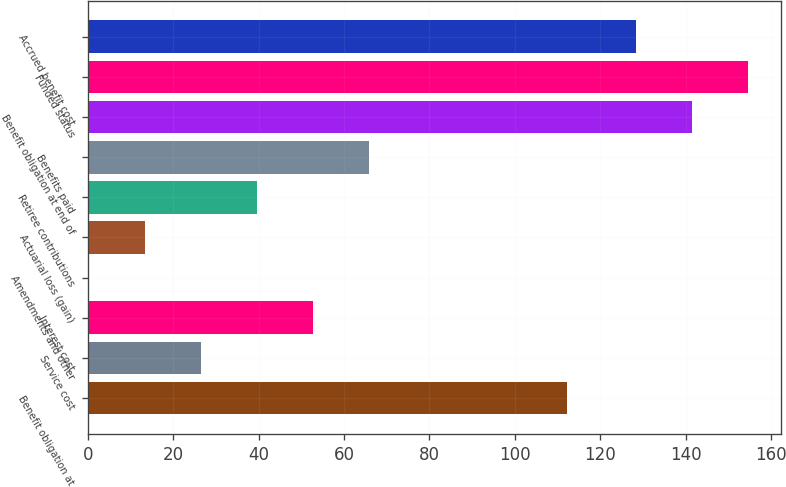<chart> <loc_0><loc_0><loc_500><loc_500><bar_chart><fcel>Benefit obligation at<fcel>Service cost<fcel>Interest cost<fcel>Amendments and other<fcel>Actuarial loss (gain)<fcel>Retiree contributions<fcel>Benefits paid<fcel>Benefit obligation at end of<fcel>Funded status<fcel>Accrued benefit cost<nl><fcel>112.3<fcel>26.48<fcel>52.66<fcel>0.3<fcel>13.39<fcel>39.57<fcel>65.75<fcel>141.39<fcel>154.48<fcel>128.3<nl></chart> 